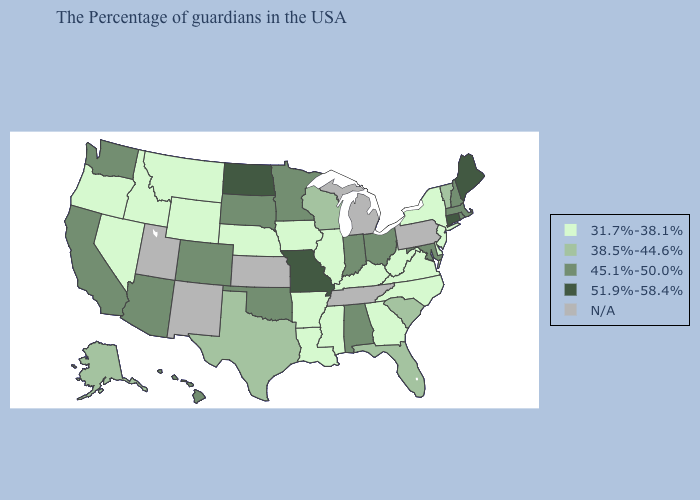Name the states that have a value in the range N/A?
Answer briefly. Pennsylvania, Michigan, Tennessee, Kansas, New Mexico, Utah. Among the states that border Arkansas , does Missouri have the highest value?
Answer briefly. Yes. Among the states that border Florida , does Alabama have the lowest value?
Quick response, please. No. What is the lowest value in the MidWest?
Answer briefly. 31.7%-38.1%. Among the states that border Pennsylvania , does Ohio have the highest value?
Write a very short answer. Yes. Among the states that border West Virginia , which have the lowest value?
Short answer required. Virginia, Kentucky. Name the states that have a value in the range 31.7%-38.1%?
Quick response, please. New York, New Jersey, Delaware, Virginia, North Carolina, West Virginia, Georgia, Kentucky, Illinois, Mississippi, Louisiana, Arkansas, Iowa, Nebraska, Wyoming, Montana, Idaho, Nevada, Oregon. Does the first symbol in the legend represent the smallest category?
Quick response, please. Yes. What is the value of Mississippi?
Keep it brief. 31.7%-38.1%. What is the value of Colorado?
Write a very short answer. 45.1%-50.0%. Among the states that border Rhode Island , which have the highest value?
Write a very short answer. Connecticut. Name the states that have a value in the range N/A?
Give a very brief answer. Pennsylvania, Michigan, Tennessee, Kansas, New Mexico, Utah. What is the value of Idaho?
Give a very brief answer. 31.7%-38.1%. Name the states that have a value in the range N/A?
Give a very brief answer. Pennsylvania, Michigan, Tennessee, Kansas, New Mexico, Utah. 